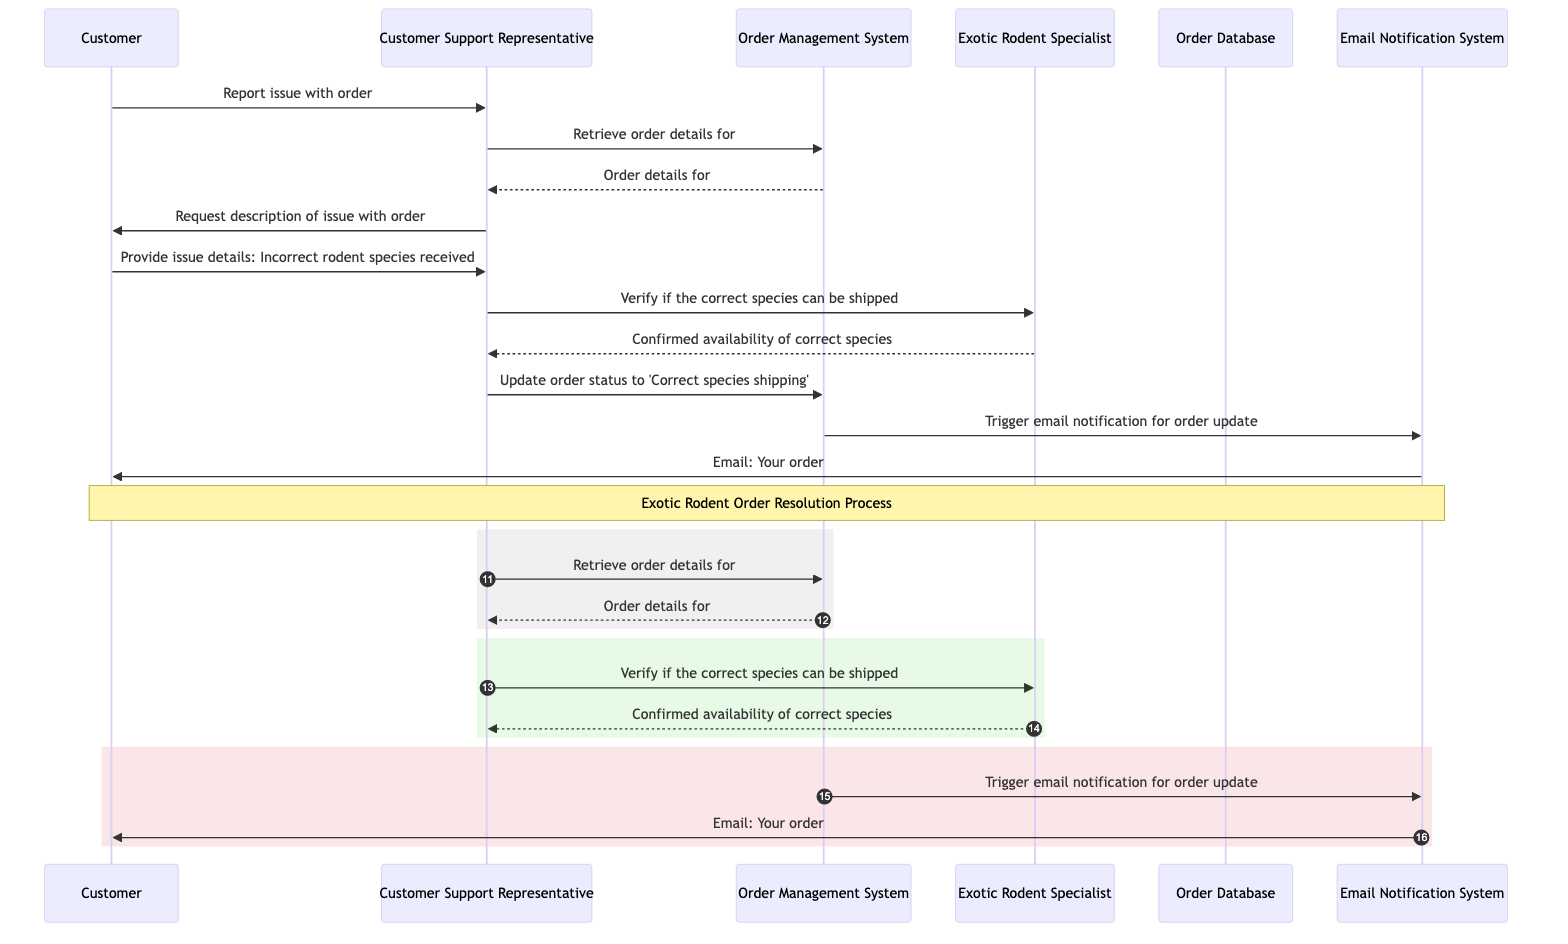What issue is the customer reporting? The customer is reporting an issue with order #12345, specifically stating that the incorrect rodent species was received. This information is shared directly from the customer to the customer support representative in the initial message.
Answer: Incorrect rodent species received Who confirms the availability of the correct species? The Exotic Rodent Specialist confirms whether the correct species can be shipped. This is evident from the interaction where the customer support representative requests verification from the exotic rodent specialist after receiving the customer's issue details.
Answer: Exotic Rodent Specialist How many distinct actors are involved in this sequence? The diagram features four distinct actors: Customer, Customer Support Representative, Order Management System, and Exotic Rodent Specialist. By counting the participants listed, we can identify the total number.
Answer: Four What action does the customer support representative take immediately after retrieving the order details? After retrieving the order details, the customer support representative requests a description of the issue with the order from the customer to understand the problem more clearly. This step follows the order detail retrieval and precedes any further action.
Answer: Request description of issue with order What is sent to the customer as part of the final notification? The final notification sent to the customer is an email stating that their order #12345 is being updated with the correct species. This final step of notifying the customer occurs after the status was updated in the order management system.
Answer: Email: Your order #12345 is being updated with the correct species What system triggers the email notification for order update? The Order Management System triggers the email notification for the order update. This can be observed from the sequence where, after the order status is updated to 'Correct species shipping,' the order management system communicates with the email notification system to initiate the email to the customer.
Answer: Order Management System Which action follows the confirmation of availability by the exotic rodent specialist? Following the confirmation from the exotic rodent specialist regarding the availability of the correct species, the customer support representative updates the order status to 'Correct species shipping' in the order management system. This action directly follows the receipt of confirmation.
Answer: Update order status to 'Correct species shipping' Which participant initiates the process by reporting an issue? The process is initiated when the Customer reports an issue related to order #12345 to the Customer Support Representative. This begins the flow of messages in the sequence diagram.
Answer: Customer 